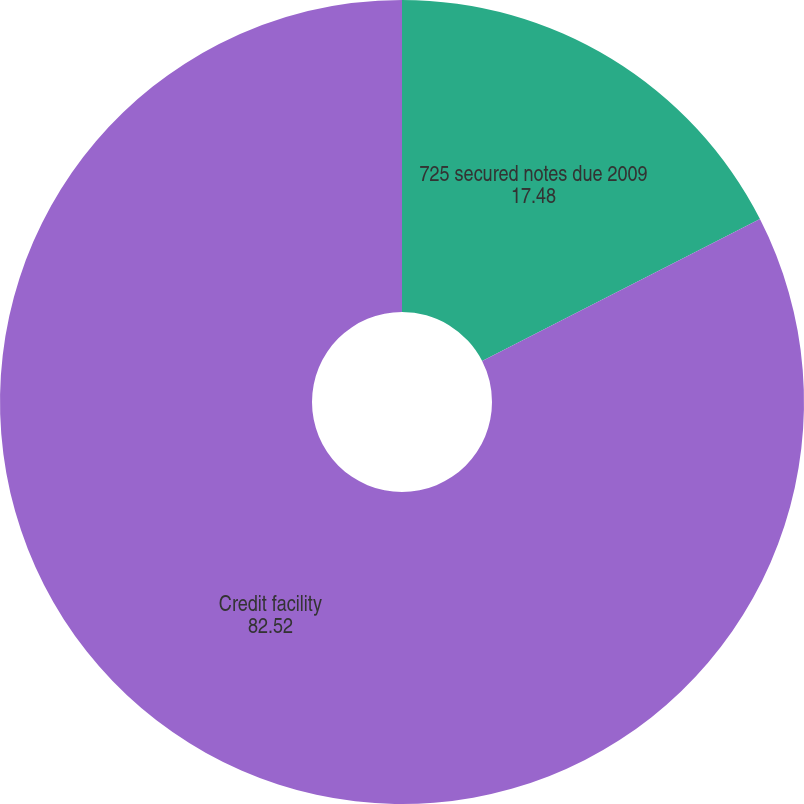Convert chart to OTSL. <chart><loc_0><loc_0><loc_500><loc_500><pie_chart><fcel>725 secured notes due 2009<fcel>Credit facility<nl><fcel>17.48%<fcel>82.52%<nl></chart> 